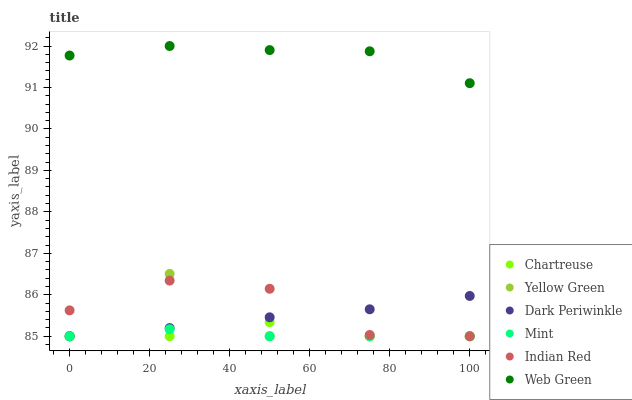Does Mint have the minimum area under the curve?
Answer yes or no. Yes. Does Web Green have the maximum area under the curve?
Answer yes or no. Yes. Does Chartreuse have the minimum area under the curve?
Answer yes or no. No. Does Chartreuse have the maximum area under the curve?
Answer yes or no. No. Is Dark Periwinkle the smoothest?
Answer yes or no. Yes. Is Yellow Green the roughest?
Answer yes or no. Yes. Is Web Green the smoothest?
Answer yes or no. No. Is Web Green the roughest?
Answer yes or no. No. Does Yellow Green have the lowest value?
Answer yes or no. Yes. Does Web Green have the lowest value?
Answer yes or no. No. Does Web Green have the highest value?
Answer yes or no. Yes. Does Chartreuse have the highest value?
Answer yes or no. No. Is Chartreuse less than Web Green?
Answer yes or no. Yes. Is Web Green greater than Chartreuse?
Answer yes or no. Yes. Does Chartreuse intersect Yellow Green?
Answer yes or no. Yes. Is Chartreuse less than Yellow Green?
Answer yes or no. No. Is Chartreuse greater than Yellow Green?
Answer yes or no. No. Does Chartreuse intersect Web Green?
Answer yes or no. No. 